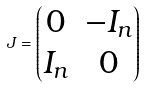Convert formula to latex. <formula><loc_0><loc_0><loc_500><loc_500>J = \begin{pmatrix} 0 & - I _ { n } \\ I _ { n } & 0 \end{pmatrix}</formula> 